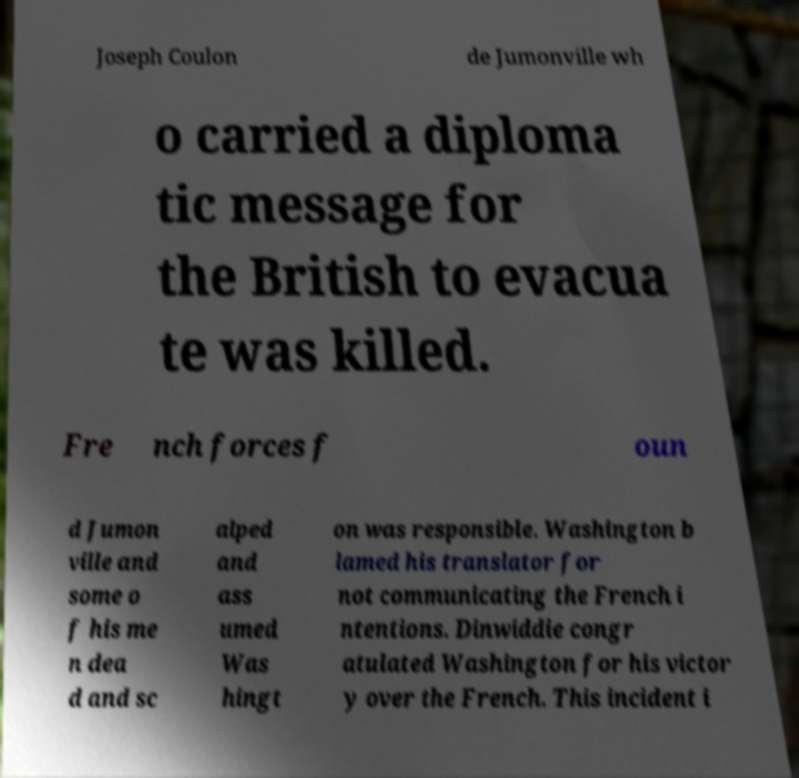Can you read and provide the text displayed in the image?This photo seems to have some interesting text. Can you extract and type it out for me? Joseph Coulon de Jumonville wh o carried a diploma tic message for the British to evacua te was killed. Fre nch forces f oun d Jumon ville and some o f his me n dea d and sc alped and ass umed Was hingt on was responsible. Washington b lamed his translator for not communicating the French i ntentions. Dinwiddie congr atulated Washington for his victor y over the French. This incident i 